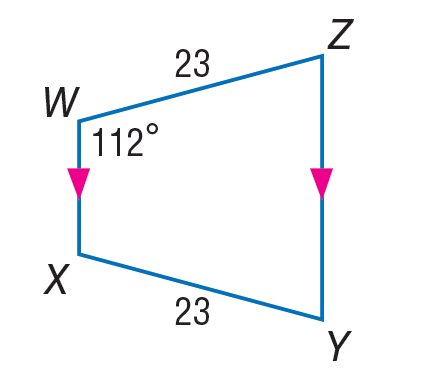Question: Find m \angle Z in the trapezoid.
Choices:
A. 23
B. 46
C. 68
D. 112
Answer with the letter. Answer: C 